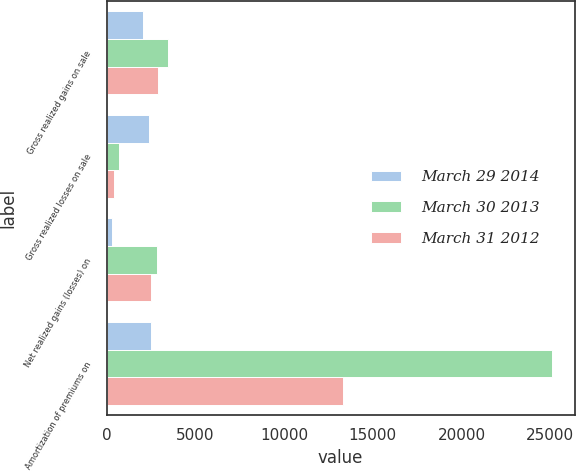Convert chart to OTSL. <chart><loc_0><loc_0><loc_500><loc_500><stacked_bar_chart><ecel><fcel>Gross realized gains on sale<fcel>Gross realized losses on sale<fcel>Net realized gains (losses) on<fcel>Amortization of premiums on<nl><fcel>March 29 2014<fcel>2080<fcel>2412<fcel>332<fcel>2515<nl><fcel>March 30 2013<fcel>3488<fcel>673<fcel>2815<fcel>25123<nl><fcel>March 31 2012<fcel>2916<fcel>401<fcel>2515<fcel>13302<nl></chart> 